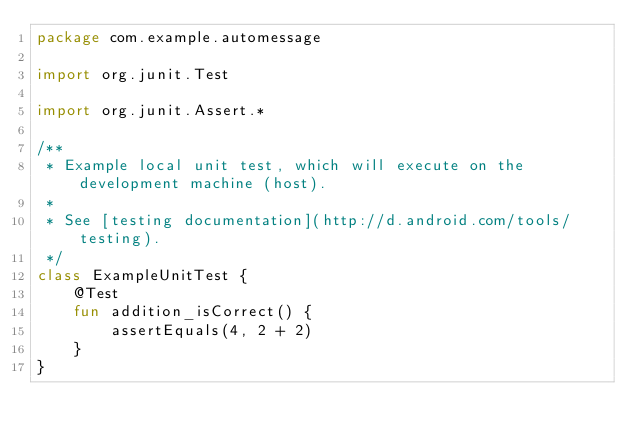<code> <loc_0><loc_0><loc_500><loc_500><_Kotlin_>package com.example.automessage

import org.junit.Test

import org.junit.Assert.*

/**
 * Example local unit test, which will execute on the development machine (host).
 *
 * See [testing documentation](http://d.android.com/tools/testing).
 */
class ExampleUnitTest {
    @Test
    fun addition_isCorrect() {
        assertEquals(4, 2 + 2)
    }
}</code> 